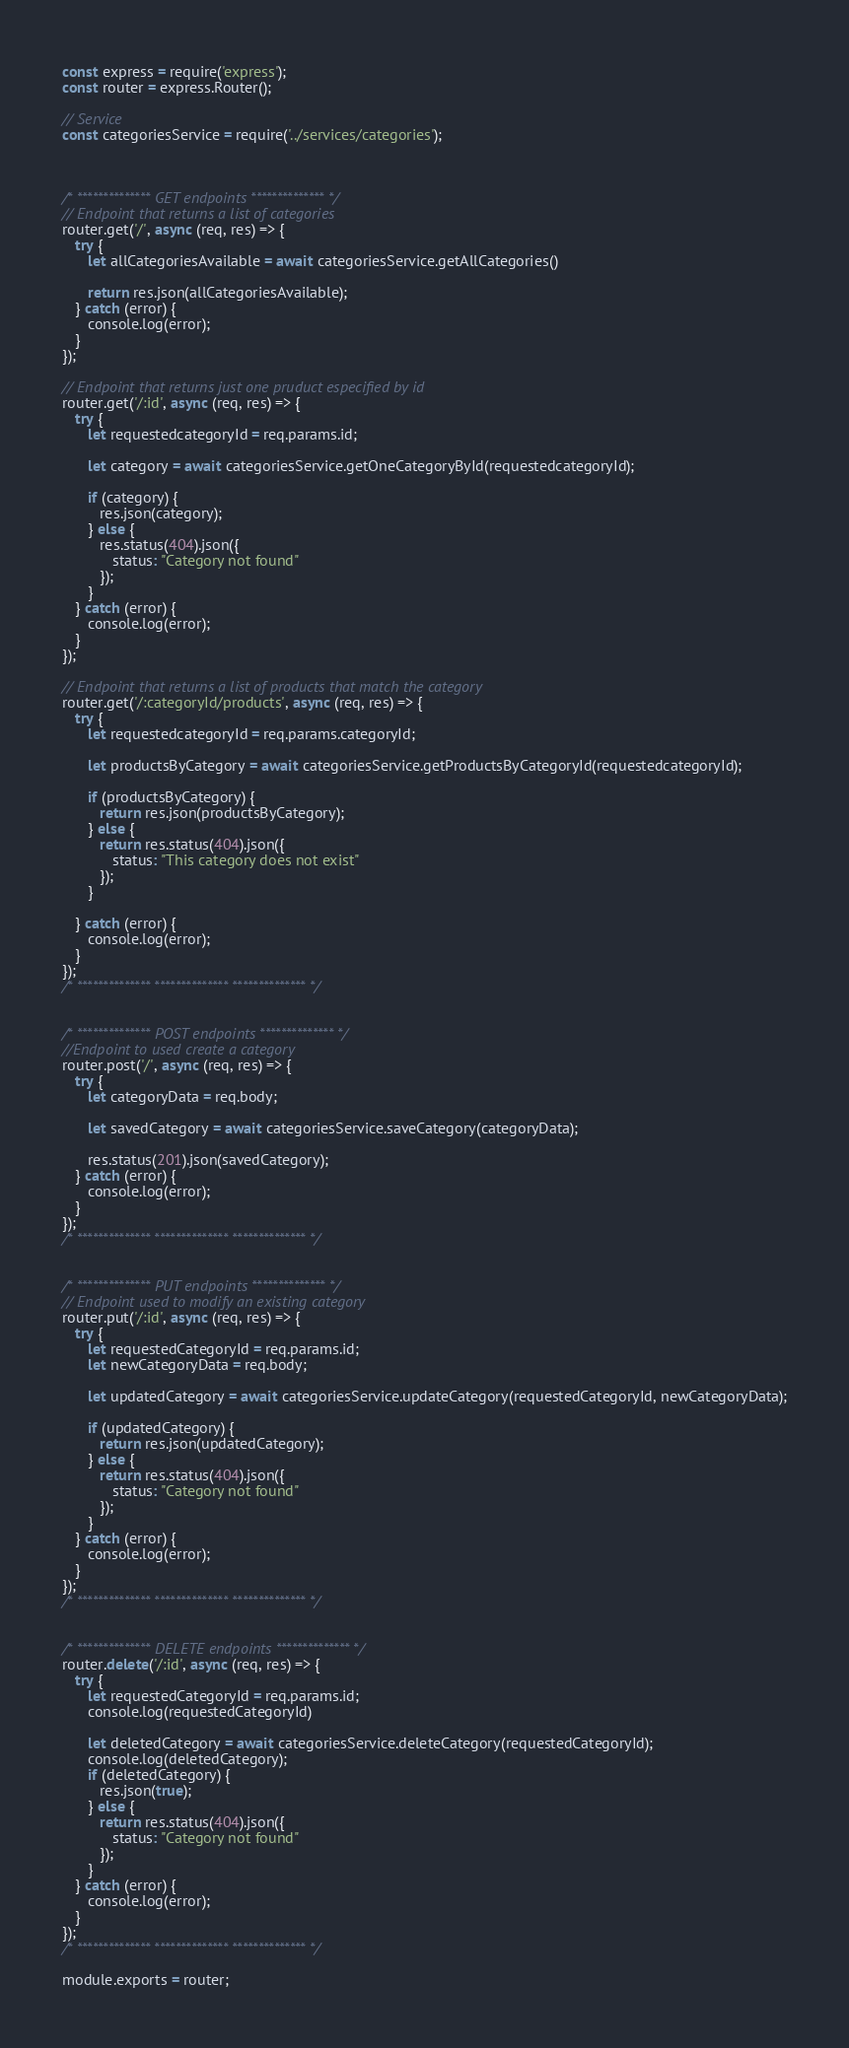<code> <loc_0><loc_0><loc_500><loc_500><_JavaScript_>const express = require('express');
const router = express.Router();

// Service
const categoriesService = require('../services/categories');



/* ************** GET endpoints ************** */
// Endpoint that returns a list of categories
router.get('/', async (req, res) => {
   try {
      let allCategoriesAvailable = await categoriesService.getAllCategories()

      return res.json(allCategoriesAvailable);
   } catch (error) {
      console.log(error);
   }
});

// Endpoint that returns just one pruduct especified by id
router.get('/:id', async (req, res) => {
   try {
      let requestedcategoryId = req.params.id;

      let category = await categoriesService.getOneCategoryById(requestedcategoryId);

      if (category) {
         res.json(category);
      } else {
         res.status(404).json({
            status: "Category not found"
         });
      }
   } catch (error) {
      console.log(error);
   }
});

// Endpoint that returns a list of products that match the category
router.get('/:categoryId/products', async (req, res) => {
   try {
      let requestedcategoryId = req.params.categoryId;

      let productsByCategory = await categoriesService.getProductsByCategoryId(requestedcategoryId);

      if (productsByCategory) {
         return res.json(productsByCategory);
      } else {
         return res.status(404).json({
            status: "This category does not exist"
         });
      }

   } catch (error) {
      console.log(error);
   }
});
/* ************** ************** ************** */


/* ************** POST endpoints ************** */
//Endpoint to used create a category
router.post('/', async (req, res) => {
   try {
      let categoryData = req.body;

      let savedCategory = await categoriesService.saveCategory(categoryData);

      res.status(201).json(savedCategory);
   } catch (error) {
      console.log(error);
   }
});
/* ************** ************** ************** */


/* ************** PUT endpoints ************** */
// Endpoint used to modify an existing category
router.put('/:id', async (req, res) => {
   try {
      let requestedCategoryId = req.params.id;
      let newCategoryData = req.body;

      let updatedCategory = await categoriesService.updateCategory(requestedCategoryId, newCategoryData);

      if (updatedCategory) {
         return res.json(updatedCategory);
      } else {
         return res.status(404).json({
            status: "Category not found"
         });
      }
   } catch (error) {
      console.log(error);
   }
});
/* ************** ************** ************** */


/* ************** DELETE endpoints ************** */
router.delete('/:id', async (req, res) => {
   try {
      let requestedCategoryId = req.params.id;
      console.log(requestedCategoryId)

      let deletedCategory = await categoriesService.deleteCategory(requestedCategoryId);
      console.log(deletedCategory);
      if (deletedCategory) {
         res.json(true);
      } else {
         return res.status(404).json({
            status: "Category not found"
         });
      }
   } catch (error) {
      console.log(error);
   }
});
/* ************** ************** ************** */

module.exports = router;</code> 